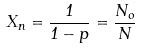Convert formula to latex. <formula><loc_0><loc_0><loc_500><loc_500>X _ { n } = \frac { 1 } { 1 - p } = \frac { N _ { o } } { N }</formula> 